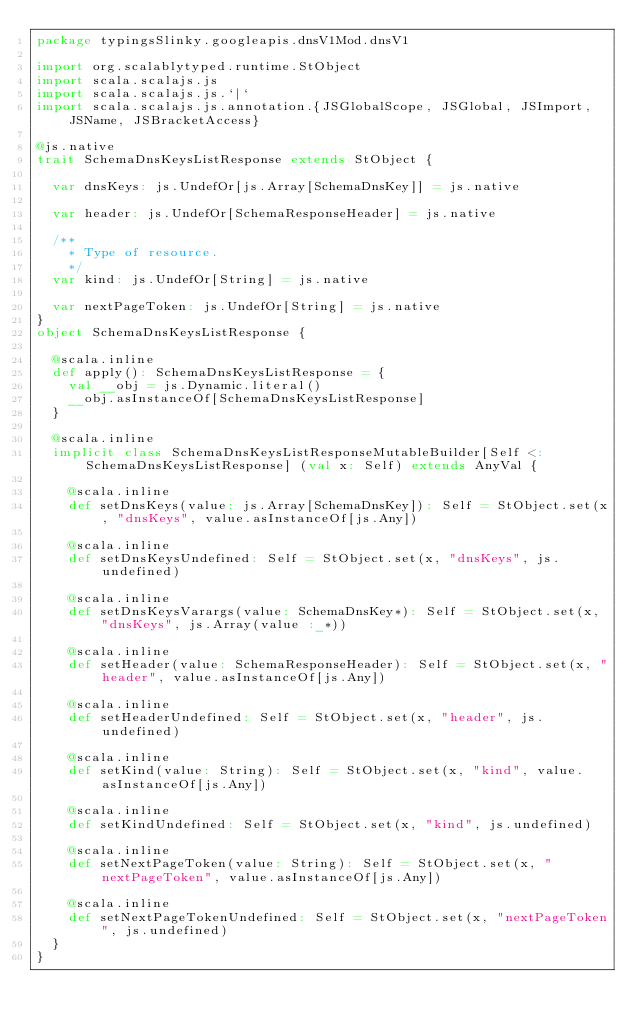<code> <loc_0><loc_0><loc_500><loc_500><_Scala_>package typingsSlinky.googleapis.dnsV1Mod.dnsV1

import org.scalablytyped.runtime.StObject
import scala.scalajs.js
import scala.scalajs.js.`|`
import scala.scalajs.js.annotation.{JSGlobalScope, JSGlobal, JSImport, JSName, JSBracketAccess}

@js.native
trait SchemaDnsKeysListResponse extends StObject {
  
  var dnsKeys: js.UndefOr[js.Array[SchemaDnsKey]] = js.native
  
  var header: js.UndefOr[SchemaResponseHeader] = js.native
  
  /**
    * Type of resource.
    */
  var kind: js.UndefOr[String] = js.native
  
  var nextPageToken: js.UndefOr[String] = js.native
}
object SchemaDnsKeysListResponse {
  
  @scala.inline
  def apply(): SchemaDnsKeysListResponse = {
    val __obj = js.Dynamic.literal()
    __obj.asInstanceOf[SchemaDnsKeysListResponse]
  }
  
  @scala.inline
  implicit class SchemaDnsKeysListResponseMutableBuilder[Self <: SchemaDnsKeysListResponse] (val x: Self) extends AnyVal {
    
    @scala.inline
    def setDnsKeys(value: js.Array[SchemaDnsKey]): Self = StObject.set(x, "dnsKeys", value.asInstanceOf[js.Any])
    
    @scala.inline
    def setDnsKeysUndefined: Self = StObject.set(x, "dnsKeys", js.undefined)
    
    @scala.inline
    def setDnsKeysVarargs(value: SchemaDnsKey*): Self = StObject.set(x, "dnsKeys", js.Array(value :_*))
    
    @scala.inline
    def setHeader(value: SchemaResponseHeader): Self = StObject.set(x, "header", value.asInstanceOf[js.Any])
    
    @scala.inline
    def setHeaderUndefined: Self = StObject.set(x, "header", js.undefined)
    
    @scala.inline
    def setKind(value: String): Self = StObject.set(x, "kind", value.asInstanceOf[js.Any])
    
    @scala.inline
    def setKindUndefined: Self = StObject.set(x, "kind", js.undefined)
    
    @scala.inline
    def setNextPageToken(value: String): Self = StObject.set(x, "nextPageToken", value.asInstanceOf[js.Any])
    
    @scala.inline
    def setNextPageTokenUndefined: Self = StObject.set(x, "nextPageToken", js.undefined)
  }
}
</code> 